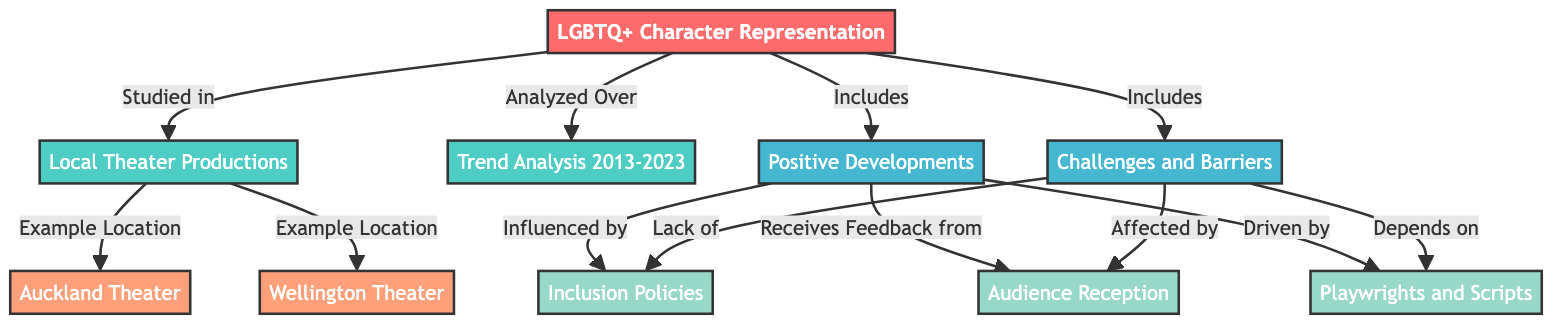What does the main topic of the diagram represent? The main topic of the diagram is 'LGBTQ+ Character Representation,' which serves as the central theme being explored in relation to theater productions.
Answer: LGBTQ+ Character Representation How many local theater locations are mentioned in the diagram? The diagram mentions two local theater locations, Auckland Theater and Wellington Theater, which are examples in the context of local theater productions.
Answer: 2 What are the two subtopics included in the representation of LGBTQ+ characters? The two subtopics included in the representation of LGBTQ+ characters are 'Positive Developments' and 'Challenges and Barriers,' encapsulating the different aspects of LGBTQ+ representation in theater.
Answer: Positive Developments, Challenges and Barriers What influences the positive developments in LGBTQ+ character representation? Positive developments are influenced by inclusion policies, receive feedback from audience reception, and are driven by playwrights and scripts, indicating that these factors contribute to advancements in representation.
Answer: Inclusion Policies, Audience Reception, Playwrights and Scripts What barriers affect the representation of LGBTQ+ characters? Barriers affecting representation include a lack of inclusion policies, audience reception issues, and dependence on the availability of suitable playwrights and scripts, highlighting challenges faced within the theater scene.
Answer: Lack of Inclusion Policies, Audience Reception Issues, Dependence on Playwrights and Scripts How does audience reception affect positive developments? Audience reception affects positive developments as it provides feedback that can influence the direction and success of LGBTQ+ character representation in theater productions, showcasing the interconnectedness of these elements.
Answer: Provides feedback Which two theaters are analyzed in relation to LGBTQ+ character representation? The two theaters analyzed in relation to LGBTQ+ character representation are Auckland Theater and Wellington Theater, both serving as case studies for examining trends over the past decade.
Answer: Auckland Theater, Wellington Theater What is analyzed over the timeframe marked in the diagram? The analysis over the timeframe marked in the diagram is 'Trend Analysis 2013-2023,' indicating a focus on how LGBTQ+ character representation has evolved during that decade.
Answer: Trend Analysis 2013-2023 